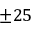<formula> <loc_0><loc_0><loc_500><loc_500>\pm 2 5</formula> 